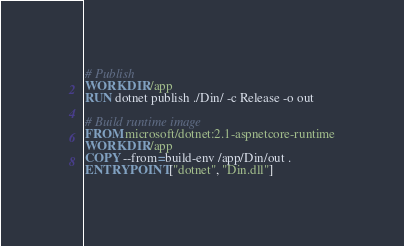<code> <loc_0><loc_0><loc_500><loc_500><_Dockerfile_># Publish
WORKDIR /app
RUN dotnet publish ./Din/ -c Release -o out

# Build runtime image
FROM microsoft/dotnet:2.1-aspnetcore-runtime
WORKDIR /app
COPY --from=build-env /app/Din/out .
ENTRYPOINT ["dotnet", "Din.dll"]
</code> 